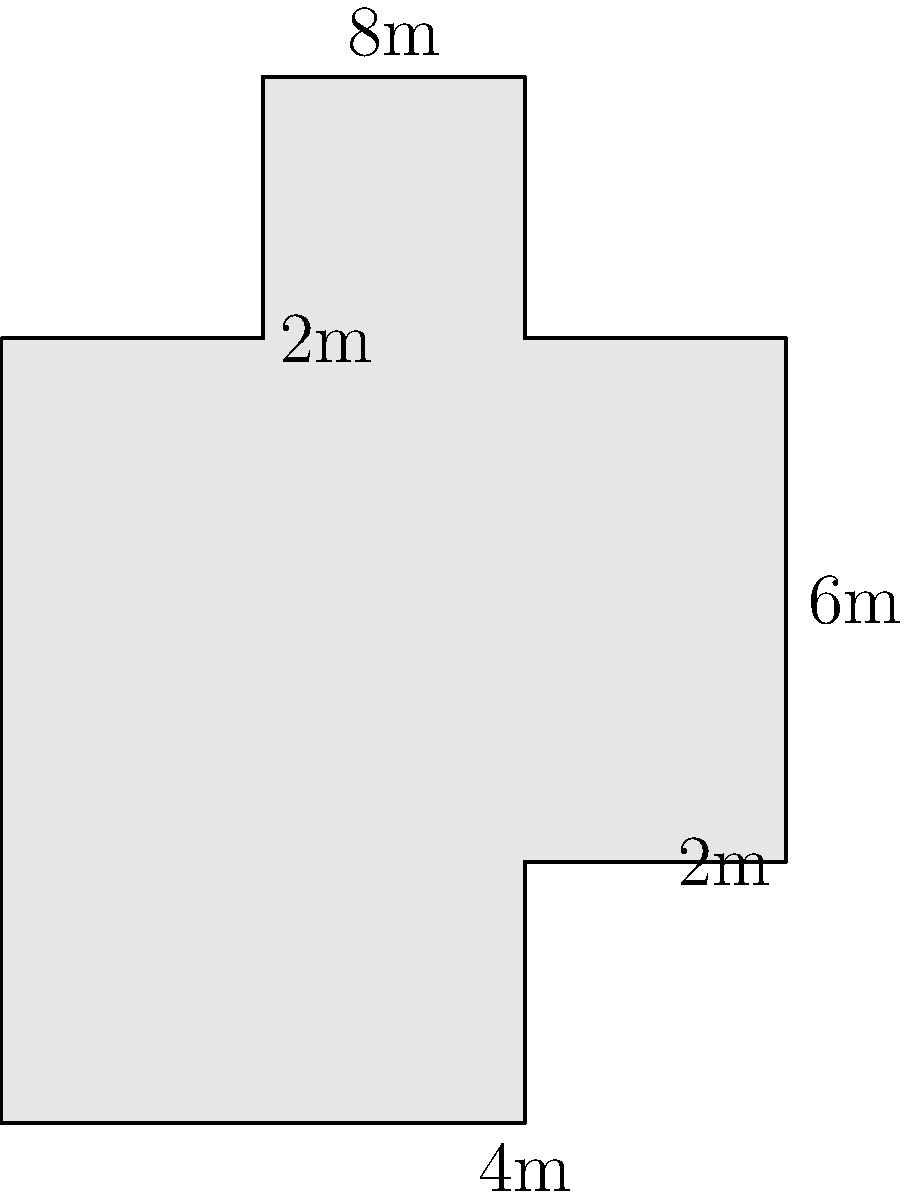Our church is planning to renovate its sanctuary, which has a unique cross-shaped floor plan. The dimensions are shown in the diagram above (in meters). As part of our outreach program, we want to calculate the total area of the sanctuary to determine how many people we can accommodate for community prayer events. What is the total area of the cross-shaped sanctuary in square meters? To find the area of the cross-shaped sanctuary, we can break it down into rectangles:

1. Main rectangle (center of the cross):
   $4m \times 6m = 24m^2$

2. Top rectangle:
   $2m \times 2m = 4m^2$

3. Bottom rectangle:
   $4m \times 2m = 8m^2$

4. Left rectangle:
   $2m \times 2m = 4m^2$

5. Right rectangle:
   $2m \times 2m = 4m^2$

Now, we sum up all the areas:

$$ \text{Total Area} = 24m^2 + 4m^2 + 8m^2 + 4m^2 + 4m^2 = 44m^2 $$

Therefore, the total area of the cross-shaped sanctuary is 44 square meters.
Answer: $44m^2$ 